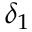Convert formula to latex. <formula><loc_0><loc_0><loc_500><loc_500>\delta _ { 1 }</formula> 